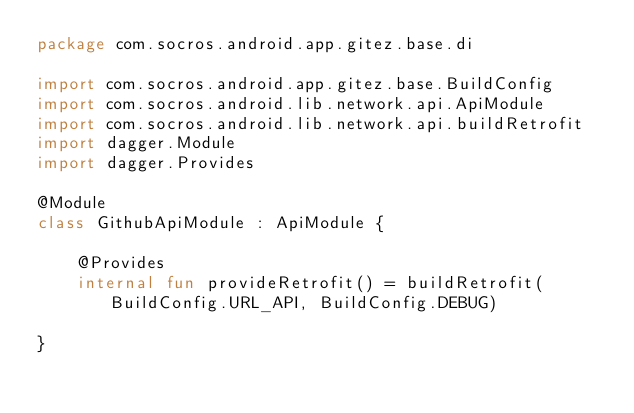<code> <loc_0><loc_0><loc_500><loc_500><_Kotlin_>package com.socros.android.app.gitez.base.di

import com.socros.android.app.gitez.base.BuildConfig
import com.socros.android.lib.network.api.ApiModule
import com.socros.android.lib.network.api.buildRetrofit
import dagger.Module
import dagger.Provides

@Module
class GithubApiModule : ApiModule {

	@Provides
	internal fun provideRetrofit() = buildRetrofit(BuildConfig.URL_API, BuildConfig.DEBUG)

}
</code> 